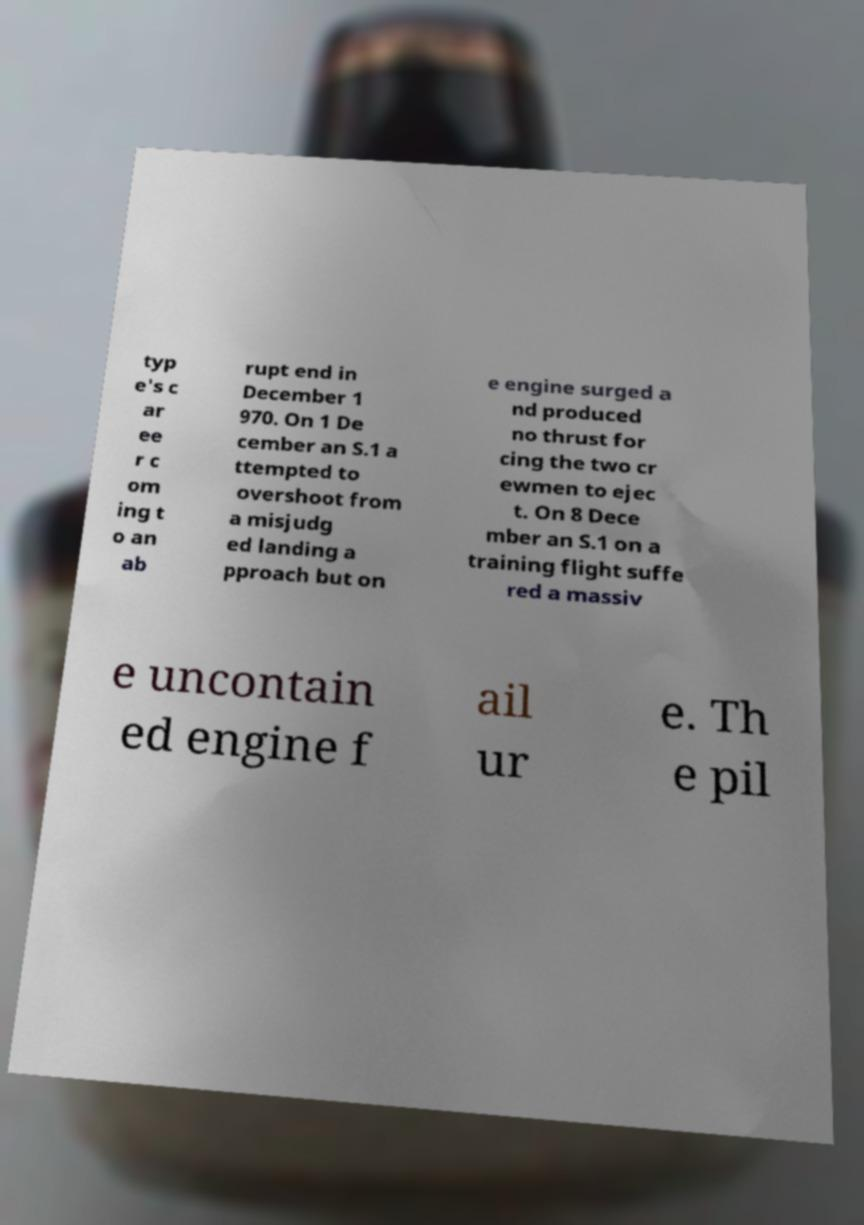Can you accurately transcribe the text from the provided image for me? typ e's c ar ee r c om ing t o an ab rupt end in December 1 970. On 1 De cember an S.1 a ttempted to overshoot from a misjudg ed landing a pproach but on e engine surged a nd produced no thrust for cing the two cr ewmen to ejec t. On 8 Dece mber an S.1 on a training flight suffe red a massiv e uncontain ed engine f ail ur e. Th e pil 